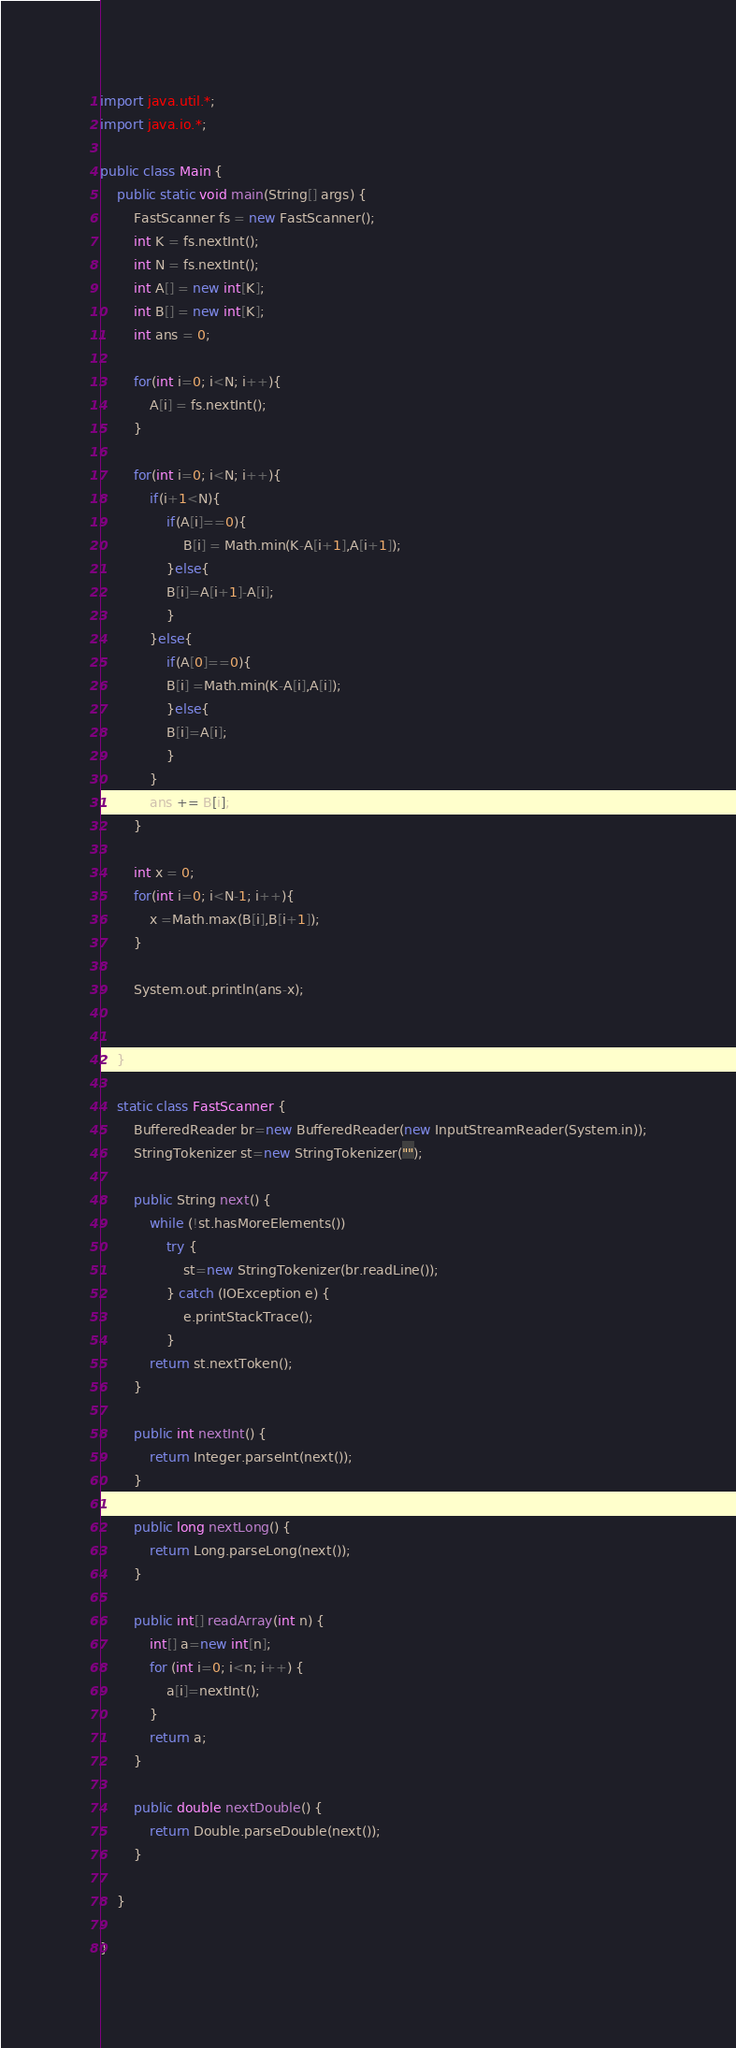Convert code to text. <code><loc_0><loc_0><loc_500><loc_500><_Java_>import java.util.*;
import java.io.*;

public class Main {	
	public static void main(String[] args) {
		FastScanner fs = new FastScanner();
		int K = fs.nextInt();
		int N = fs.nextInt();
		int A[] = new int[K];
		int B[] = new int[K];
		int ans = 0;

		for(int i=0; i<N; i++){
			A[i] = fs.nextInt();
		}

		for(int i=0; i<N; i++){
			if(i+1<N){
				if(A[i]==0){
					B[i] = Math.min(K-A[i+1],A[i+1]);				
			    }else{
			    B[i]=A[i+1]-A[i];
			    }
			}else{
				if(A[0]==0){
				B[i] =Math.min(K-A[i],A[i]);
				}else{
			    B[i]=A[i];
				}
			}
			ans += B[i]; 
		}

		int x = 0;
		for(int i=0; i<N-1; i++){
			x =Math.max(B[i],B[i+1]);
		}

		System.out.println(ans-x);		
		
 
	}
	
	static class FastScanner {
		BufferedReader br=new BufferedReader(new InputStreamReader(System.in));
		StringTokenizer st=new StringTokenizer("");

		public String next() {
			while (!st.hasMoreElements())
				try {
					st=new StringTokenizer(br.readLine());
				} catch (IOException e) {
					e.printStackTrace();
				}
			return st.nextToken();
		}

		public int nextInt() {
			return Integer.parseInt(next());
		}

		public long nextLong() {
			return Long.parseLong(next());
		}

		public int[] readArray(int n) {
			int[] a=new int[n];
			for (int i=0; i<n; i++) {
				a[i]=nextInt();
			}
			return a;
		}

		public double nextDouble() {
			return Double.parseDouble(next());
		}

	}
	
}
</code> 